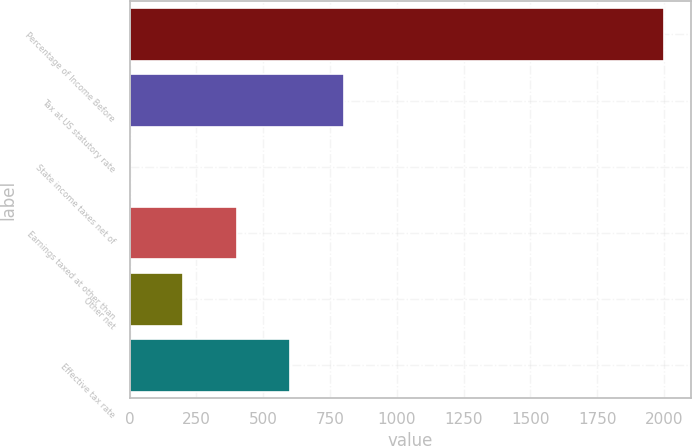Convert chart. <chart><loc_0><loc_0><loc_500><loc_500><bar_chart><fcel>Percentage of Income Before<fcel>Tax at US statutory rate<fcel>State income taxes net of<fcel>Earnings taxed at other than<fcel>Other net<fcel>Effective tax rate<nl><fcel>2001<fcel>800.76<fcel>0.6<fcel>400.68<fcel>200.64<fcel>600.72<nl></chart> 